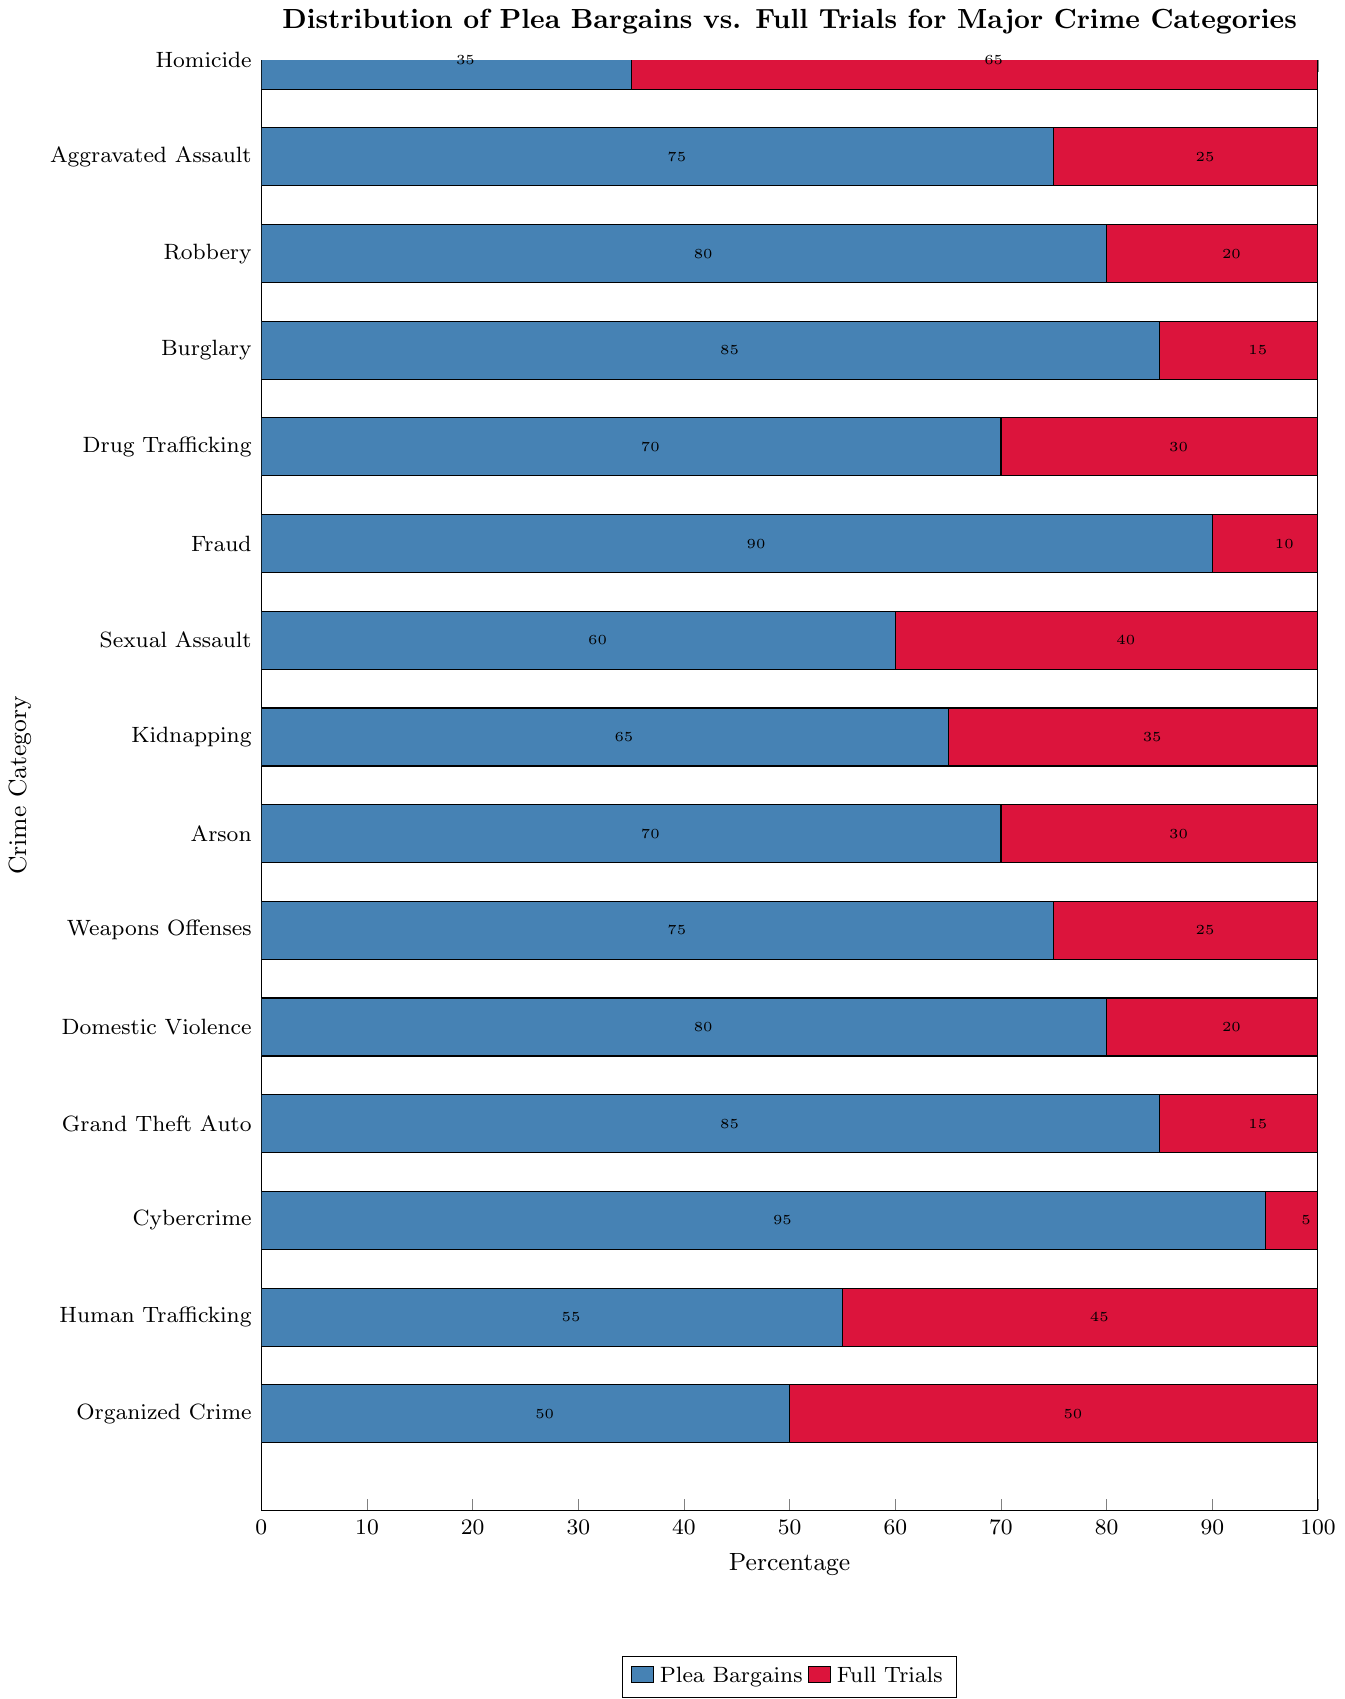Which crime category has the highest percentage of plea bargains? The category with the longest blue bar represents the highest percentage of plea bargains. Cybercrime has the longest blue bar, indicating the highest plea bargains at 95%.
Answer: Cybercrime What is the difference in the percentage of plea bargains and full trials for Homicide? For Homicide, the plea bargains percentage is 35% and the full trials percentage is 65%. The difference is calculated by subtracting the plea bargains percentage from the full trials percentage: 65% - 35% = 30%.
Answer: 30% Which crime categories have more than 50% full trials? Categories with more than 50% full trials are represented by having longer red bars than blue bars. These categories are Homicide, Human Trafficking, and Organized Crime.
Answer: Homicide, Human Trafficking, Organized Crime Of the crime categories with more than 75% plea bargains, which one has the lowest percentage? Categories with more than 75% plea bargains are Robbery, Burglary, Fraud, Domestic Violence, Grand Theft Auto, and Cybercrime. Among these, Robbery has the lowest percentage of plea bargains at 80%.
Answer: Robbery What is the average percentage of full trials for the categories: Drug Trafficking, Sexual Assault, and Kidnapping? To find the average, sum the full trials percentages for Drug Trafficking (30%), Sexual Assault (40%), and Kidnapping (35%), and then divide by the number of categories: (30% + 40% + 35%) / 3 = 35%.
Answer: 35% Which crime category has an equal percentage of plea bargains and full trials? The category where blue and red bars are of equal length is Organized Crime, indicating 50% plea bargains and 50% full trials.
Answer: Organized Crime Compare the percentage of plea bargains in Aggravated Assault with Kidnapping. Which one is higher and by how much? Aggravated Assault has 75% plea bargains, and Kidnapping has 65% plea bargains. The difference is calculated by subtracting Kidnapping's percentage from Aggravated Assault's percentage: 75% - 65% = 10%.
Answer: Aggravated Assault by 10% What is the sum of the percentages of full trials for Aggravated Assault, Robbery, and Burglary? Sum the full trials percentages for Aggravated Assault (25%), Robbery (20%), and Burglary (15%): 25% + 20% + 15% = 60%.
Answer: 60% How many crime categories have a plea bargain percentage greater than 70%? The categories with blue bars representing more than 70% are Aggravated Assault, Robbery, Burglary, Drug Trafficking, Fraud, Domestic Violence, Grand Theft Auto, and Cybercrime. There are 8 such categories.
Answer: 8 Between Sexual Assault and Kidnapping, which category has a higher percentage of full trials and by how much? Sexual Assault has 40% full trials, and Kidnapping has 35% full trials. Subtracting Kidnapping's percentage from Sexual Assault's gives: 40% - 35% = 5%.
Answer: Sexual Assault by 5% 